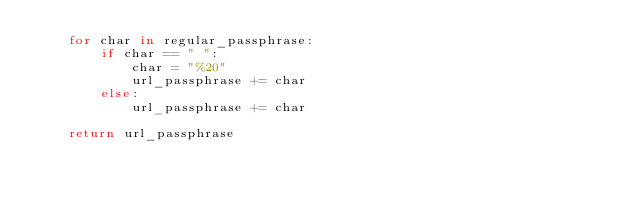Convert code to text. <code><loc_0><loc_0><loc_500><loc_500><_Python_>    for char in regular_passphrase:
        if char == " ":
            char = "%20"
            url_passphrase += char
        else:
            url_passphrase += char

    return url_passphrase
</code> 